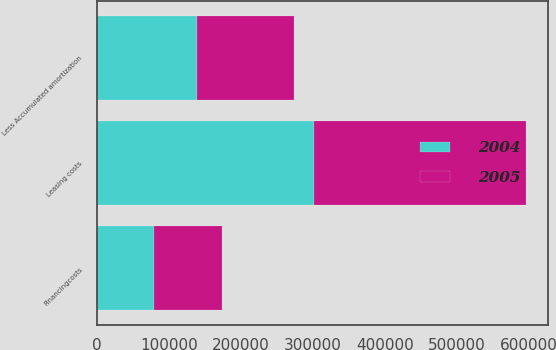<chart> <loc_0><loc_0><loc_500><loc_500><stacked_bar_chart><ecel><fcel>Leasing costs<fcel>Financingcosts<fcel>Less Accumulated amortization<nl><fcel>2004<fcel>302173<fcel>79032<fcel>138545<nl><fcel>2005<fcel>294405<fcel>95244<fcel>134699<nl></chart> 